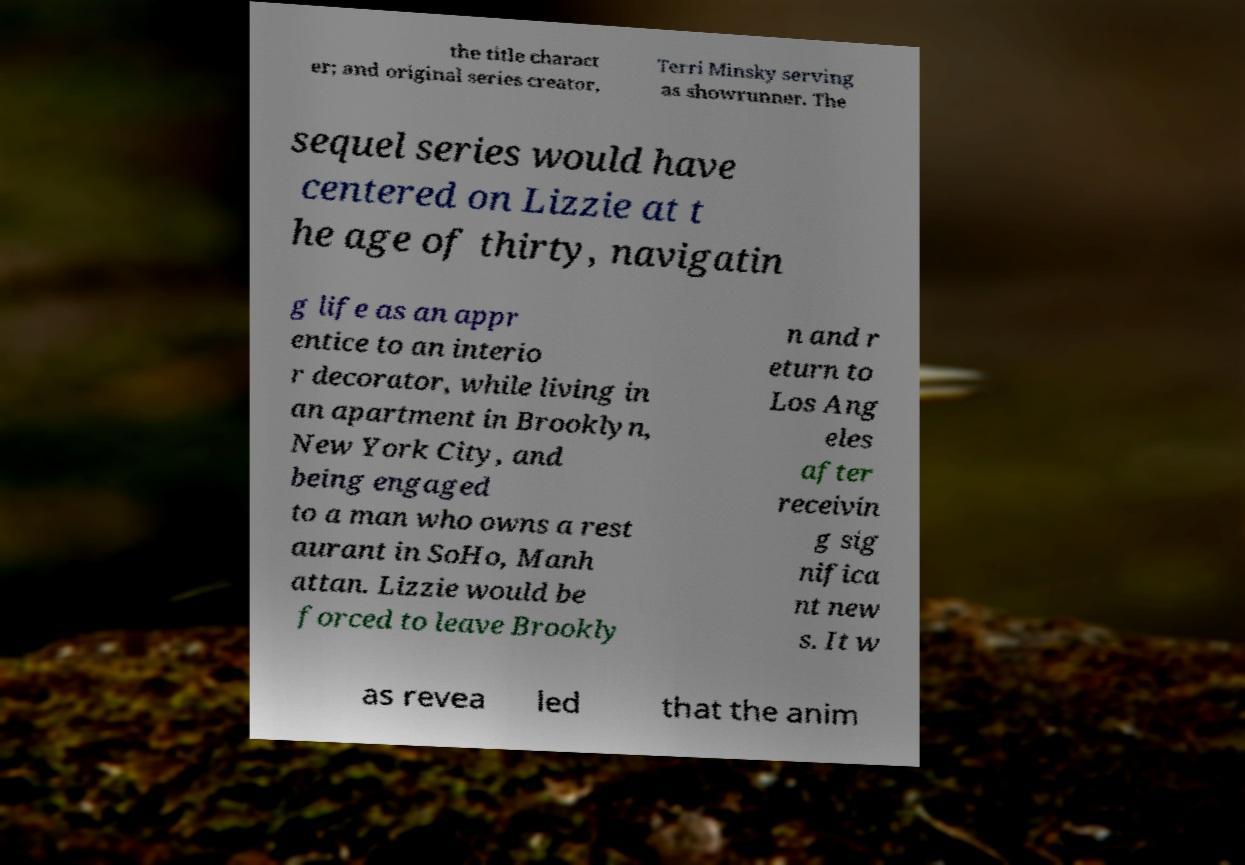For documentation purposes, I need the text within this image transcribed. Could you provide that? the title charact er; and original series creator, Terri Minsky serving as showrunner. The sequel series would have centered on Lizzie at t he age of thirty, navigatin g life as an appr entice to an interio r decorator, while living in an apartment in Brooklyn, New York City, and being engaged to a man who owns a rest aurant in SoHo, Manh attan. Lizzie would be forced to leave Brookly n and r eturn to Los Ang eles after receivin g sig nifica nt new s. It w as revea led that the anim 